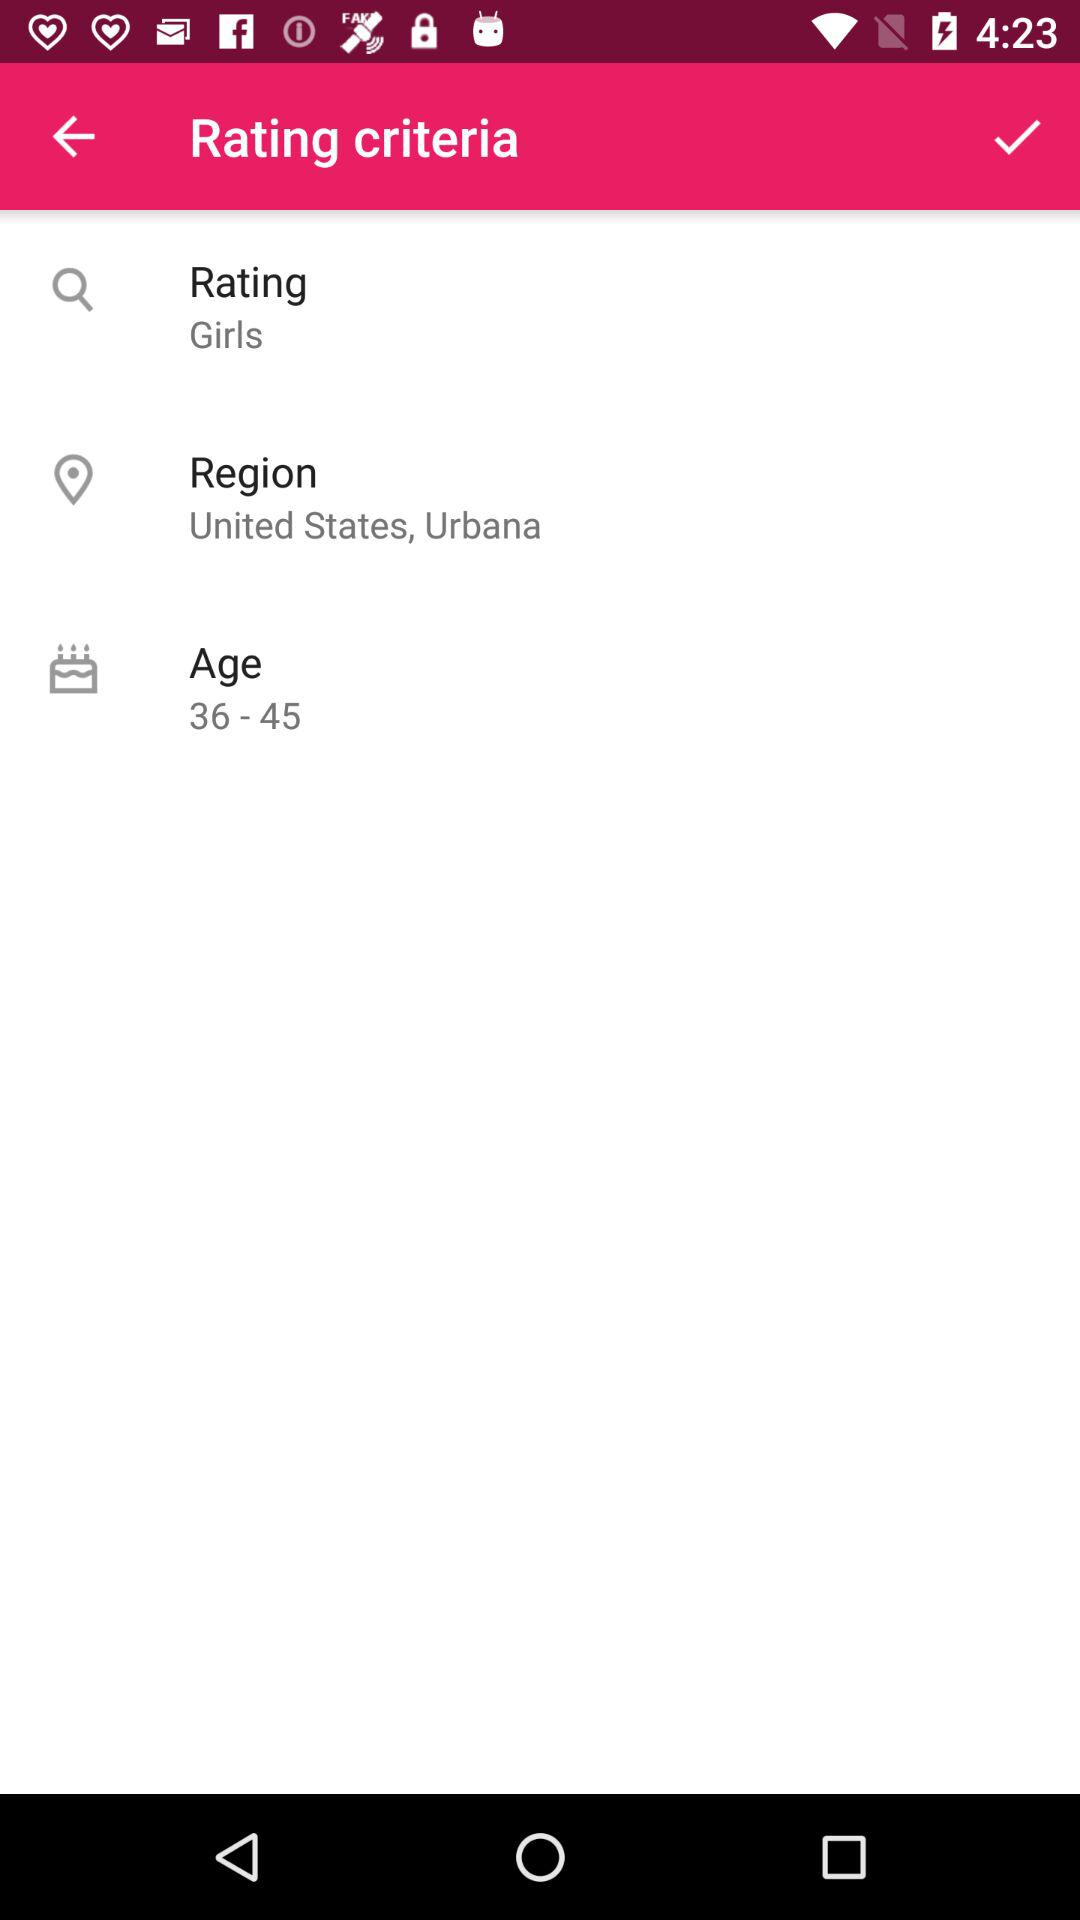How many rating criteria are there? 3 